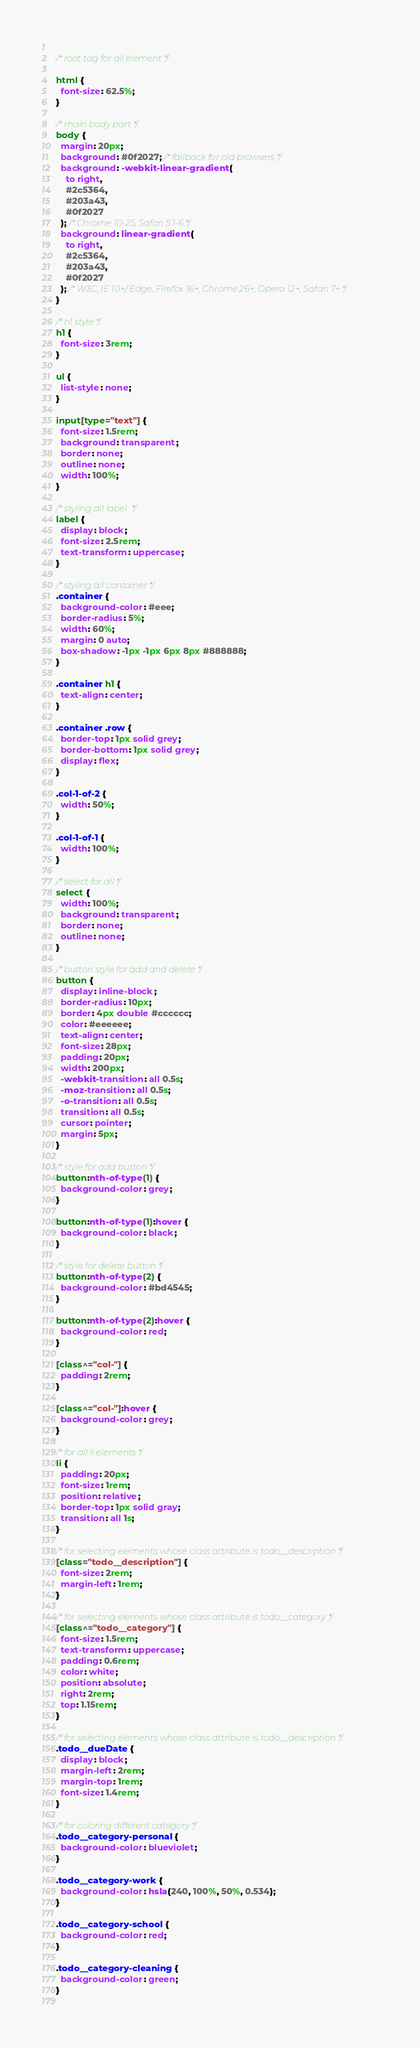<code> <loc_0><loc_0><loc_500><loc_500><_CSS_>  
  /* root tag for all element */
  
  html {
    font-size: 62.5%;
  }
  
  /* main body part */
  body {
    margin: 20px;
    background: #0f2027; /* fallback for old browsers */
    background: -webkit-linear-gradient(
      to right,
      #2c5364,
      #203a43,
      #0f2027
    ); /* Chrome 10-25, Safari 5.1-6 */
    background: linear-gradient(
      to right,
      #2c5364,
      #203a43,
      #0f2027
    ); /* W3C, IE 10+/ Edge, Firefox 16+, Chrome 26+, Opera 12+, Safari 7+ */
  }
  
  /* h1 style */
  h1 {
    font-size: 3rem;
  }
  
  ul {
    list-style: none;
  }
  
  input[type="text"] {
    font-size: 1.5rem;
    background: transparent;
    border: none;
    outline: none;
    width: 100%;
  }
  
  /* styling all label  */
  label {
    display: block;
    font-size: 2.5rem;
    text-transform: uppercase;
  }
  
  /* styling all container */
  .container {
    background-color: #eee;
    border-radius: 5%;
    width: 60%;
    margin: 0 auto;
    box-shadow: -1px -1px 6px 8px #888888;
  }
  
  .container h1 {
    text-align: center;
  }
  
  .container .row {
    border-top: 1px solid grey;
    border-bottom: 1px solid grey;
    display: flex;
  }
  
  .col-1-of-2 {
    width: 50%;
  }
  
  .col-1-of-1 {
    width: 100%;
  }
  
  /* select for all */
  select {
    width: 100%;
    background: transparent;
    border: none;
    outline: none;
  }
  
  /* button style for add and delete */
  button {
    display: inline-block;
    border-radius: 10px;
    border: 4px double #cccccc;
    color: #eeeeee;
    text-align: center;
    font-size: 28px;
    padding: 20px;
    width: 200px;
    -webkit-transition: all 0.5s;
    -moz-transition: all 0.5s;
    -o-transition: all 0.5s;
    transition: all 0.5s;
    cursor: pointer;
    margin: 5px;
  }
  
  /* style for add button */
  button:nth-of-type(1) {
    background-color: grey;
  }
  
  button:nth-of-type(1):hover {
    background-color: black;
  }
  
  /* style for delete button */
  button:nth-of-type(2) {
    background-color: #bd4545;
  }
  
  button:nth-of-type(2):hover {
    background-color: red;
  }
  
  [class^="col-"] {
    padding: 2rem;
  }
  
  [class^="col-"]:hover {
    background-color: grey;
  }
  
  /* for all li elements */
  li {
    padding: 20px;
    font-size: 1rem;
    position: relative;
    border-top: 1px solid gray;
    transition: all 1s;
  }
  
  /* for selecting elements whose class attribute is todo__description */
  [class="todo__description"] {
    font-size: 2rem;
    margin-left: 1rem;
  }
  
  /* for selecting elements whose class attribute is todo__category */
  [class^="todo__category"] {
    font-size: 1.5rem;
    text-transform: uppercase;
    padding: 0.6rem;
    color: white;
    position: absolute;
    right: 2rem;
    top: 1.15rem;
  }
  
  /* for selecting elements whose class attribute is todo__description */
  .todo__dueDate {
    display: block;
    margin-left: 2rem;
    margin-top: 1rem;
    font-size: 1.4rem;
  }
  
  /* for coloring different category */
  .todo__category-personal {
    background-color: blueviolet;
  }
  
  .todo__category-work {
    background-color: hsla(240, 100%, 50%, 0.534);
  }
  
  .todo__category-school {
    background-color: red;
  }
  
  .todo__category-cleaning {
    background-color: green;
  }
  </code> 